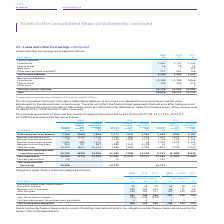According to Bt Group Plc's financial document, What was the collateral received on swaps in 2019? According to the financial document, £638m. The relevant text states: "a Includes collateral received on swaps of £638m (2017/18: £525m, 2016/17: £702m)...." Also, What does the carrying value reflect? balances at amortised cost adjusted for accrued interest and fair value adjustments to the relevant loans or borrowings.. The document states: "rrying values disclosed in the above table reflect balances at amortised cost adjusted for accrued interest and fair value adjustments to the relevant..." Also, What was the amount of listed bonds in 2019, 2018 and 2017 respectively? The document contains multiple relevant values: 1,367, 1,702, 1,539 (in millions). From the document: "Current liabilities Listed bonds 1,367 1,702 1,539 Finance leases 16 18 15 Bank loans – – 352 Other loans and bank overdrafts a 717 561 726 Current li..." Also, can you calculate: What is the change in listed bonds from 2018 to 2019? Based on the calculation: 1,367 - 1,702, the result is -335 (in millions). This is based on the information: "Current liabilities Listed bonds 1,367 1,702 1,539 Finance leases 16 18 15 Bank loans – – 352 Other loans and bank overdrafts a 717 561 726 Current liabilities Listed bonds 1,367 1,702 1,539 Finance l..." The key data points involved are: 1,367, 1,702. Also, can you calculate: What is the average Finance leases for 2017-2019? To answer this question, I need to perform calculations using the financial data. The calculation is: (16 + 18 + 15) / 3, which equals 16.33 (in millions). This is based on the information: "ies Listed bonds 1,367 1,702 1,539 Finance leases 16 18 15 Bank loans – – 352 Other loans and bank overdrafts a 717 561 726 Listed bonds 1,367 1,702 1,539 Finance leases 16 18 15 Bank loans – – 352 Ot..." The key data points involved are: 15, 18. Additionally, In which year(s) are there are no bank loans? The document shows two values: 2019 and 2018 (in millions). Locate and analyze finance leases in row 5. From the document: "At 31 March 2019 £m 2018 £m 2017 £m At 31 March 2019 £m 2018 £m 2017 £m..." 